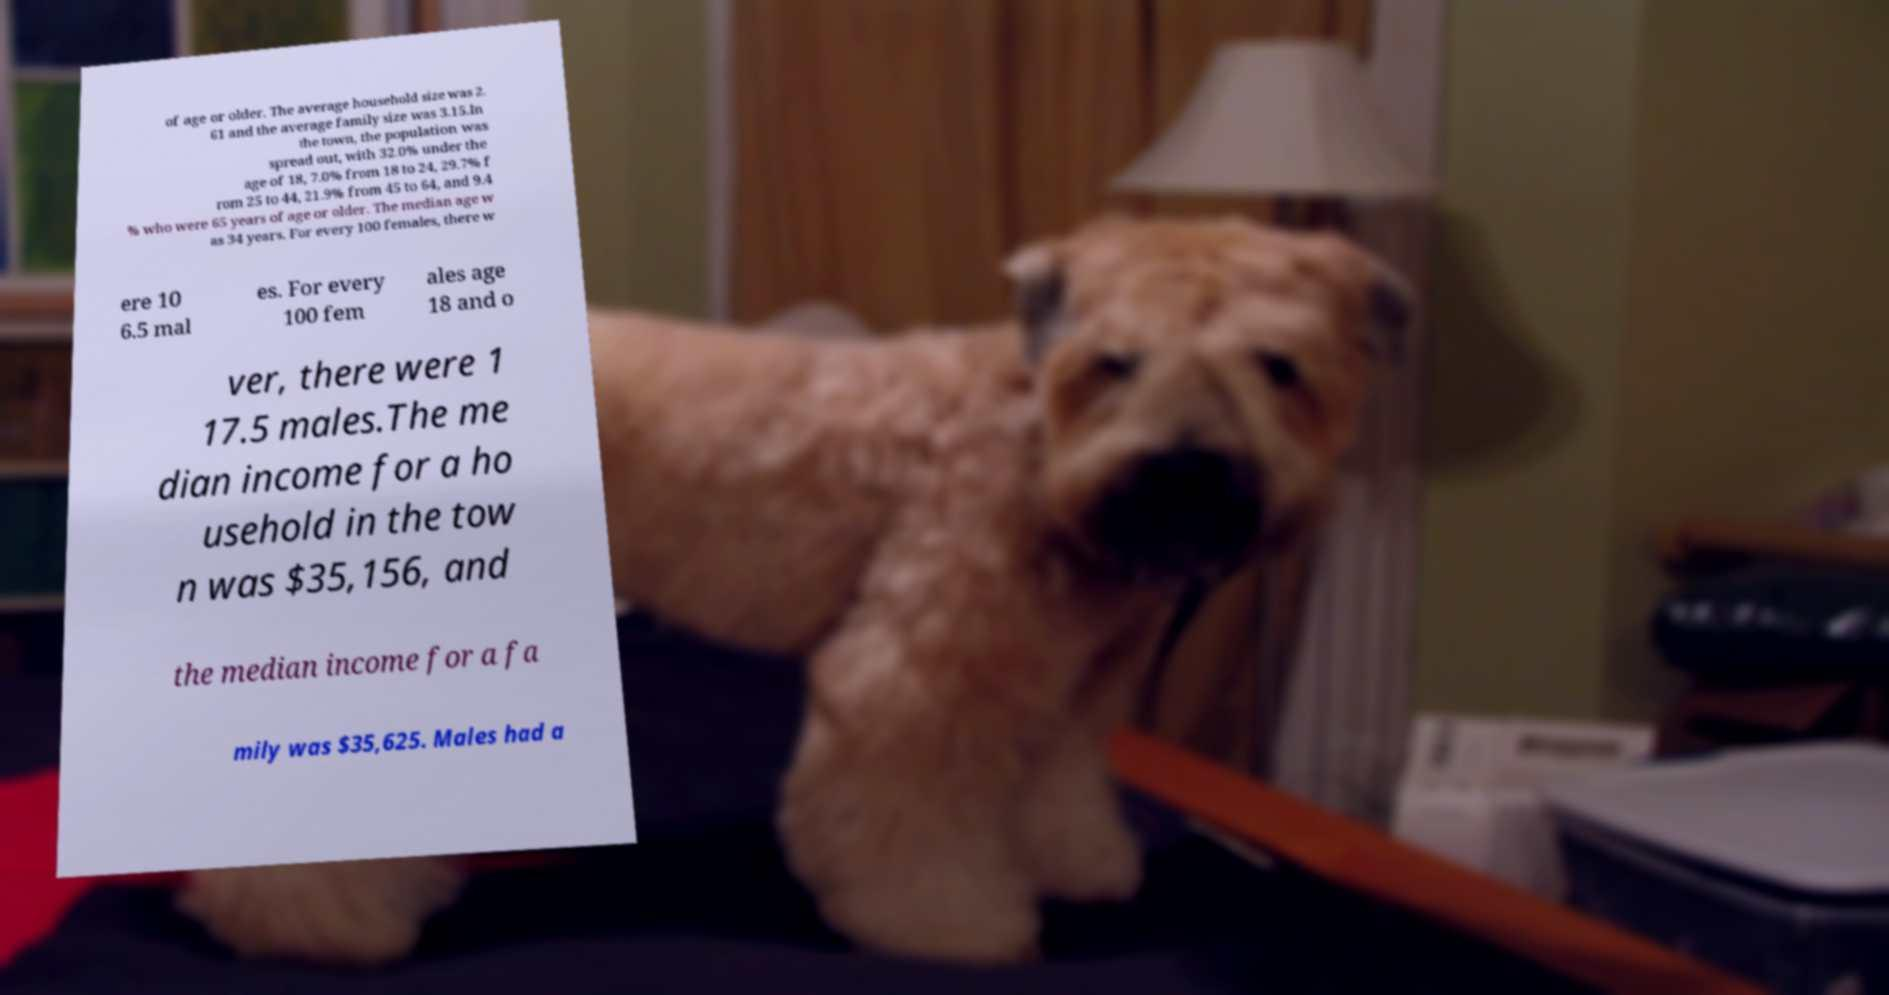Please read and relay the text visible in this image. What does it say? of age or older. The average household size was 2. 61 and the average family size was 3.15.In the town, the population was spread out, with 32.0% under the age of 18, 7.0% from 18 to 24, 29.7% f rom 25 to 44, 21.9% from 45 to 64, and 9.4 % who were 65 years of age or older. The median age w as 34 years. For every 100 females, there w ere 10 6.5 mal es. For every 100 fem ales age 18 and o ver, there were 1 17.5 males.The me dian income for a ho usehold in the tow n was $35,156, and the median income for a fa mily was $35,625. Males had a 